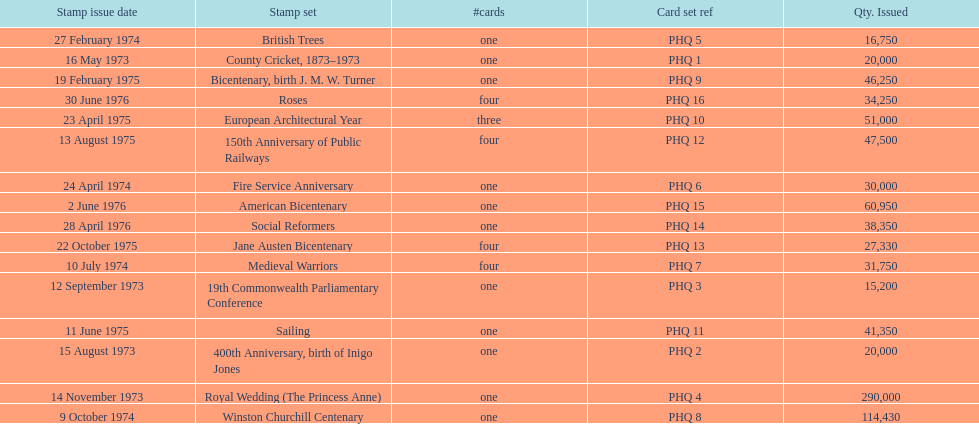Which stamp sets contained more than one card? Medieval Warriors, European Architectural Year, 150th Anniversary of Public Railways, Jane Austen Bicentenary, Roses. Of those stamp sets, which contains a unique number of cards? European Architectural Year. 